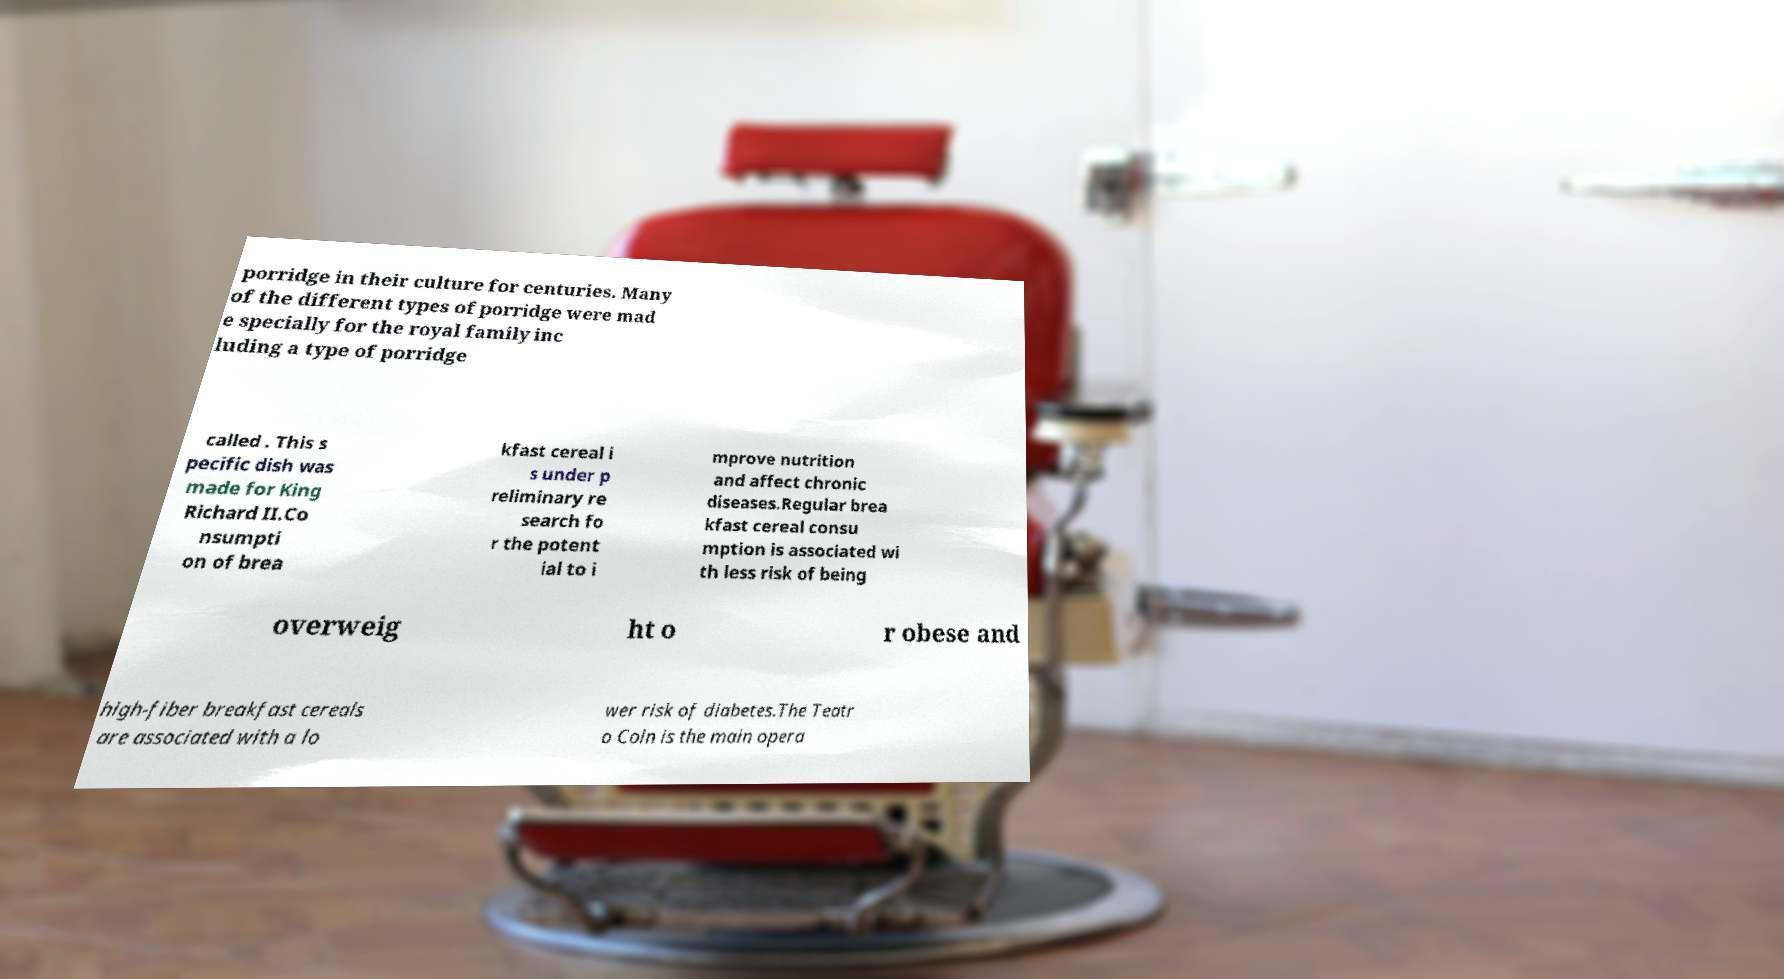For documentation purposes, I need the text within this image transcribed. Could you provide that? porridge in their culture for centuries. Many of the different types of porridge were mad e specially for the royal family inc luding a type of porridge called . This s pecific dish was made for King Richard II.Co nsumpti on of brea kfast cereal i s under p reliminary re search fo r the potent ial to i mprove nutrition and affect chronic diseases.Regular brea kfast cereal consu mption is associated wi th less risk of being overweig ht o r obese and high-fiber breakfast cereals are associated with a lo wer risk of diabetes.The Teatr o Coln is the main opera 